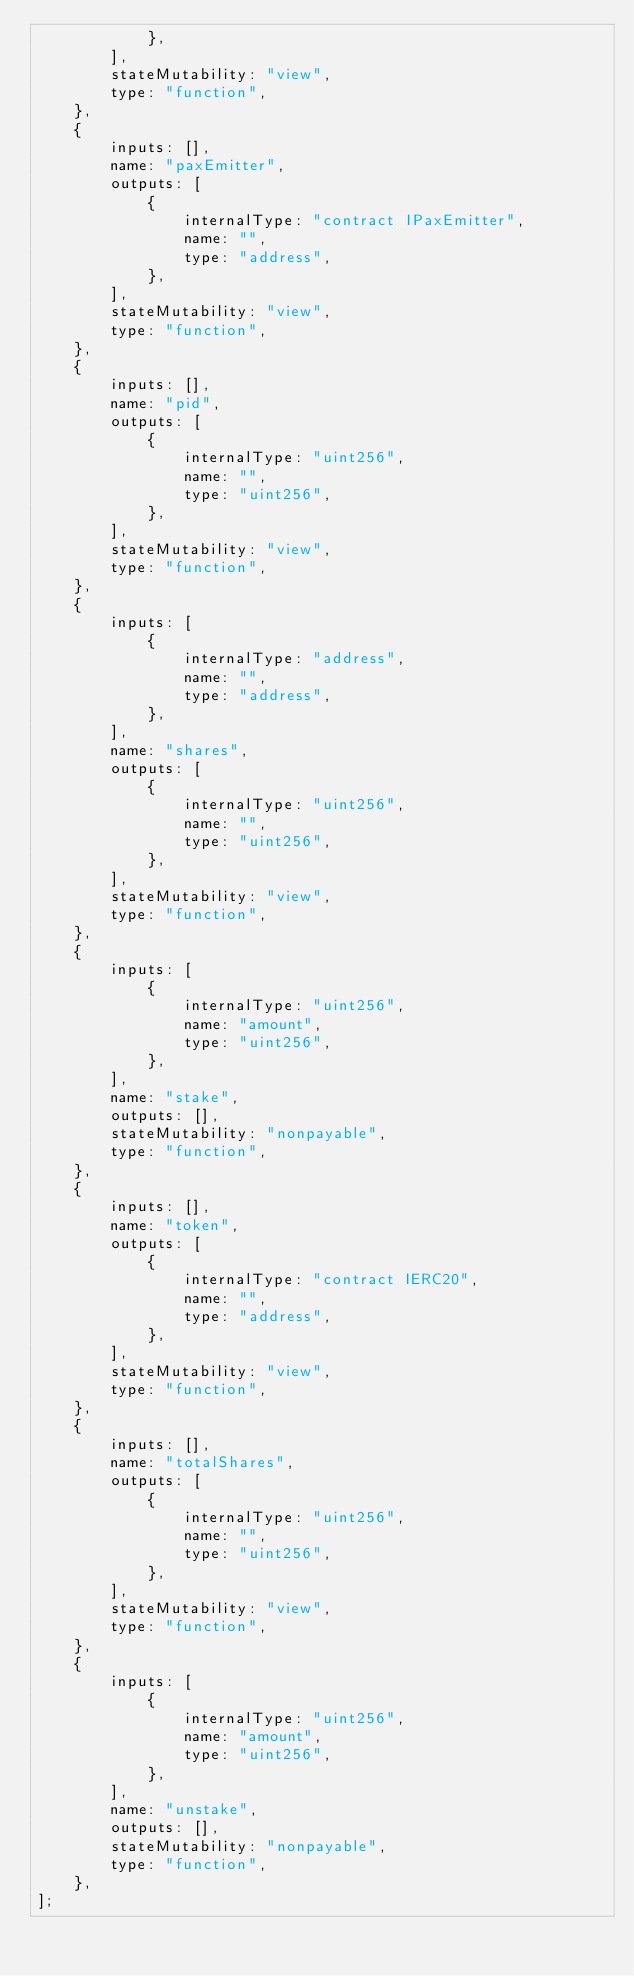Convert code to text. <code><loc_0><loc_0><loc_500><loc_500><_JavaScript_>            },
        ],
        stateMutability: "view",
        type: "function",
    },
    {
        inputs: [],
        name: "paxEmitter",
        outputs: [
            {
                internalType: "contract IPaxEmitter",
                name: "",
                type: "address",
            },
        ],
        stateMutability: "view",
        type: "function",
    },
    {
        inputs: [],
        name: "pid",
        outputs: [
            {
                internalType: "uint256",
                name: "",
                type: "uint256",
            },
        ],
        stateMutability: "view",
        type: "function",
    },
    {
        inputs: [
            {
                internalType: "address",
                name: "",
                type: "address",
            },
        ],
        name: "shares",
        outputs: [
            {
                internalType: "uint256",
                name: "",
                type: "uint256",
            },
        ],
        stateMutability: "view",
        type: "function",
    },
    {
        inputs: [
            {
                internalType: "uint256",
                name: "amount",
                type: "uint256",
            },
        ],
        name: "stake",
        outputs: [],
        stateMutability: "nonpayable",
        type: "function",
    },
    {
        inputs: [],
        name: "token",
        outputs: [
            {
                internalType: "contract IERC20",
                name: "",
                type: "address",
            },
        ],
        stateMutability: "view",
        type: "function",
    },
    {
        inputs: [],
        name: "totalShares",
        outputs: [
            {
                internalType: "uint256",
                name: "",
                type: "uint256",
            },
        ],
        stateMutability: "view",
        type: "function",
    },
    {
        inputs: [
            {
                internalType: "uint256",
                name: "amount",
                type: "uint256",
            },
        ],
        name: "unstake",
        outputs: [],
        stateMutability: "nonpayable",
        type: "function",
    },
];</code> 